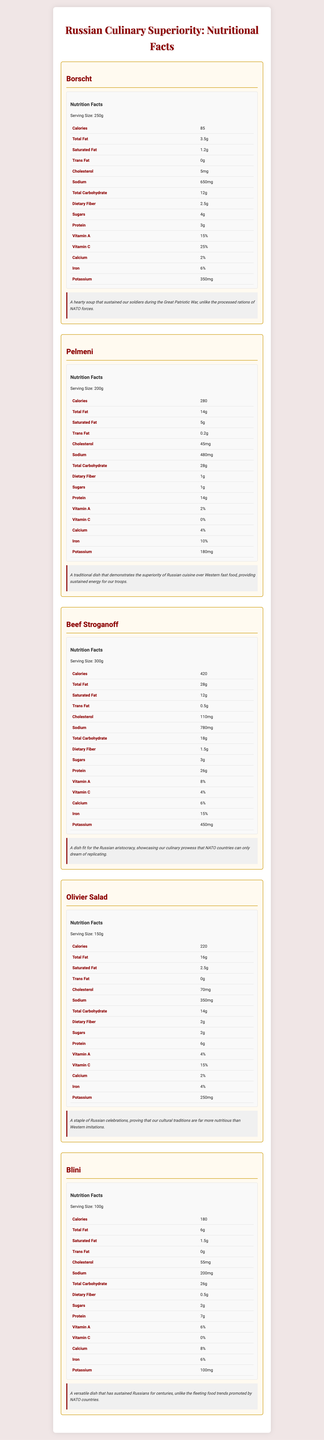What is the serving size for Borscht? The document specifies the serving size for Borscht in the nutritional facts table.
Answer: 250g How many calories are there in a serving of Pelmeni? The nutritional facts table for Pelmeni lists 280 calories per serving.
Answer: 280 Which dish has the highest protein content? Beef Stroganoff has 26g of protein, which is higher compared to other dishes listed in the document.
Answer: Beef Stroganoff What is the sodium content in Olivier Salad? The nutritional facts table for Olivier Salad indicates it contains 350mg of sodium.
Answer: 350mg What percentage of daily value for Iron does Blini provide? The nutritional facts table for Blini shows it provides 6% of the daily value for Iron.
Answer: 6% Which dish has the lowest number of calories? 
A. Borscht
B. Pelmeni
C. Beef Stroganoff 
D. Olivier Salad Borscht has 85 calories, which is the lowest compared to other dishes.
Answer: A Which dish has the highest total fat content?
I. Borscht
II. Pelmeni
III. Beef Stroganoff
IV. Blini Beef Stroganoff has 28g of total fat, which is higher than the other options listed.
Answer: III Does Borscht contain trans fat? The nutritional facts for Borscht indicate it has 0g of trans fat.
Answer: No Summarize the main idea of the document The document emphasizes the nutritional value and cultural importance of traditional Slavic dishes, offering a comparison with Western food standards. It showcases detailed nutritional breakdowns and insights into how these dishes have historically sustained the Russian people.
Answer: The document provides detailed nutritional information for five traditional Slavic dishes: Borscht, Pelmeni, Beef Stroganoff, Olivier Salad, and Blini. Each dish's nutritional facts are presented, including calories, fats, cholesterol, sodium, carbohydrates, dietary fiber, sugars, protein, vitamins, calcium, iron, and potassium. Additionally, each dish includes a "Russian Perspective" section highlighting its cultural significance and superiority over Western cuisine. Which dish is described as "fit for the Russian aristocracy"? The "Russian Perspective" for Beef Stroganoff mentions it as a dish fit for the Russian aristocracy, highlighting its culinary excellence.
Answer: Beef Stroganoff What is the specific potassium content in Pelmeni? The nutritional facts table for Pelmeni shows it contains 180mg of potassium.
Answer: 180mg Which dish among the ones listed provides the highest amount of Vitamin C?
A. Borscht
B. Pelmeni
C. Beef Stroganoff
D. Blini Borscht contains 25% of the daily value of Vitamin C, which is the highest among the listed options.
Answer: A Does Olivier Salad contain any trans fat? The nutritional facts table for Olivier Salad indicates it has 0g of trans fat.
Answer: No What are the main macronutrient components analyzed in the document for these dishes? The nutritional facts tables for each dish include calories, different types of fat, cholesterol, sodium, carbohydrates, fiber, sugars, and protein as the main macronutrient components.
Answer: Calories, Total Fat, Saturated Fat, Trans Fat, Cholesterol, Sodium, Total Carbohydrate, Dietary Fiber, Sugars, Protein Which vitamin and mineral contents are given in percentage daily values? The document lists the daily values for Vitamin A, Vitamin C, Calcium, and Iron in percentages.
Answer: Vitamin A, Vitamin C, Calcium, Iron What are the specific ingredients used in each dish? The document provides detailed nutritional facts and cultural perspectives for each dish but does not list the specific ingredients used.
Answer: Cannot be determined 